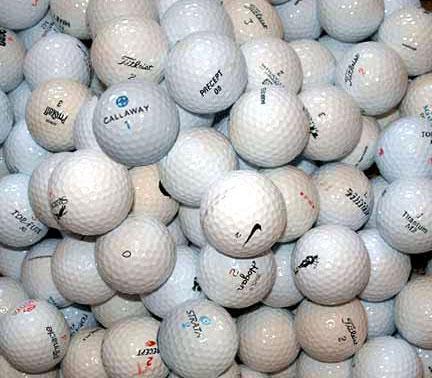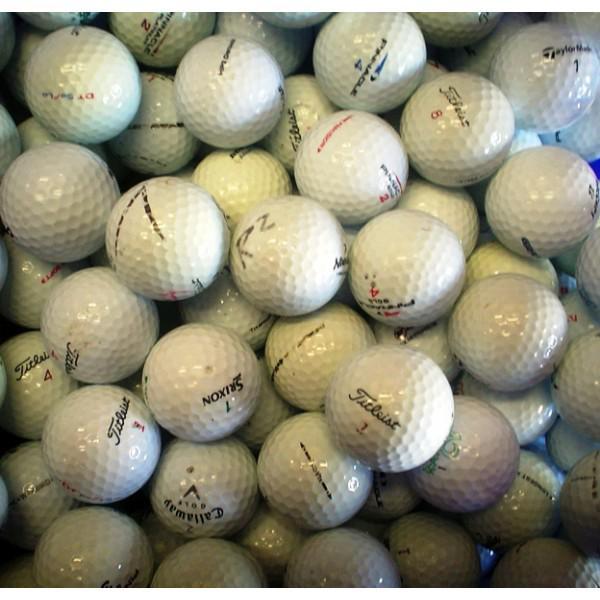The first image is the image on the left, the second image is the image on the right. Considering the images on both sides, is "Some of the balls are colorful." valid? Answer yes or no. No. 